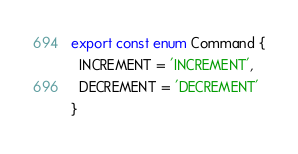Convert code to text. <code><loc_0><loc_0><loc_500><loc_500><_TypeScript_>export const enum Command {
  INCREMENT = 'INCREMENT',
  DECREMENT = 'DECREMENT'
}
</code> 